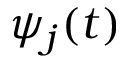Convert formula to latex. <formula><loc_0><loc_0><loc_500><loc_500>\psi _ { j } ( t )</formula> 